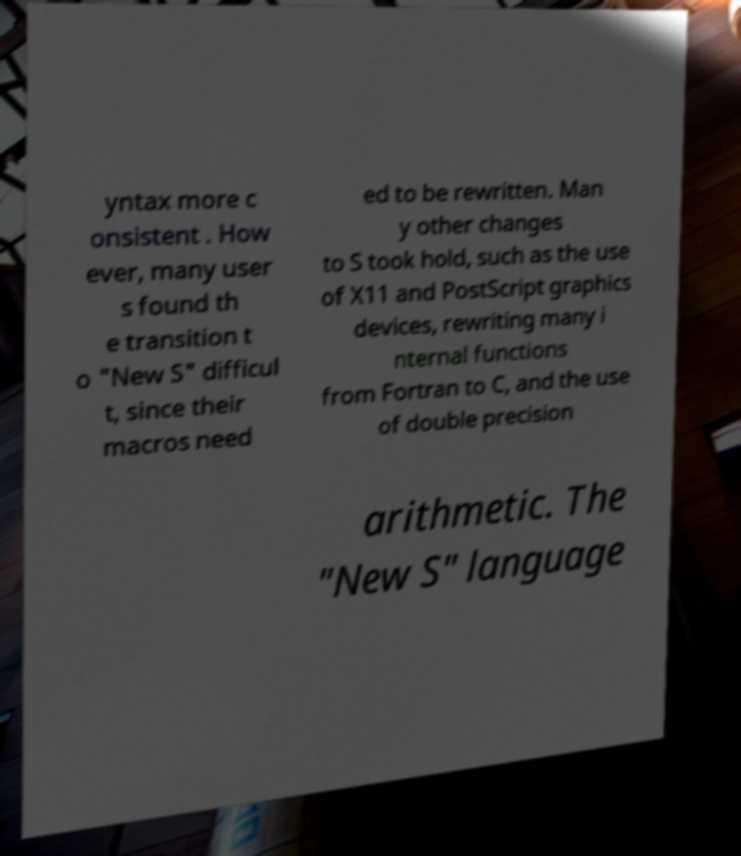Please read and relay the text visible in this image. What does it say? yntax more c onsistent . How ever, many user s found th e transition t o "New S" difficul t, since their macros need ed to be rewritten. Man y other changes to S took hold, such as the use of X11 and PostScript graphics devices, rewriting many i nternal functions from Fortran to C, and the use of double precision arithmetic. The "New S" language 